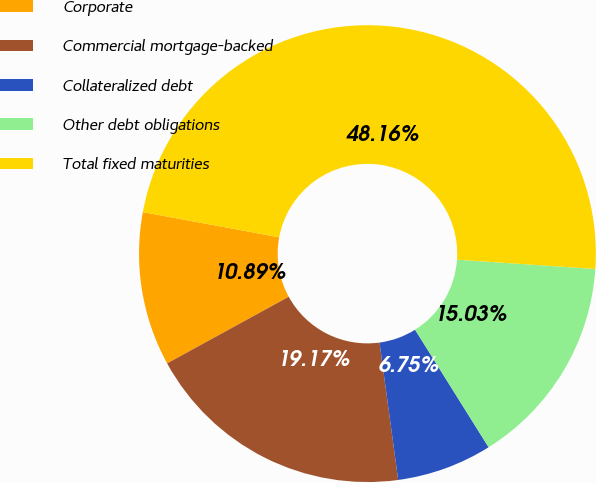<chart> <loc_0><loc_0><loc_500><loc_500><pie_chart><fcel>Corporate<fcel>Commercial mortgage-backed<fcel>Collateralized debt<fcel>Other debt obligations<fcel>Total fixed maturities<nl><fcel>10.89%<fcel>19.17%<fcel>6.75%<fcel>15.03%<fcel>48.16%<nl></chart> 